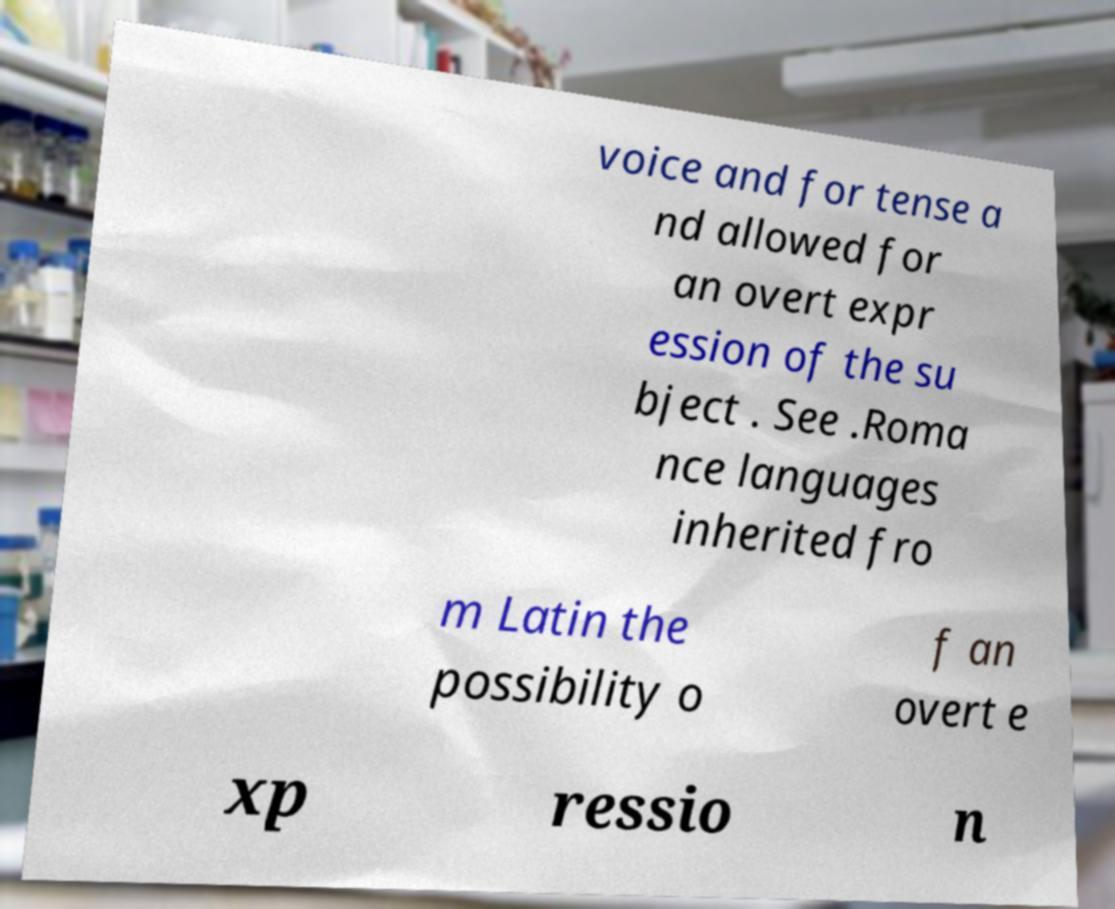There's text embedded in this image that I need extracted. Can you transcribe it verbatim? voice and for tense a nd allowed for an overt expr ession of the su bject . See .Roma nce languages inherited fro m Latin the possibility o f an overt e xp ressio n 